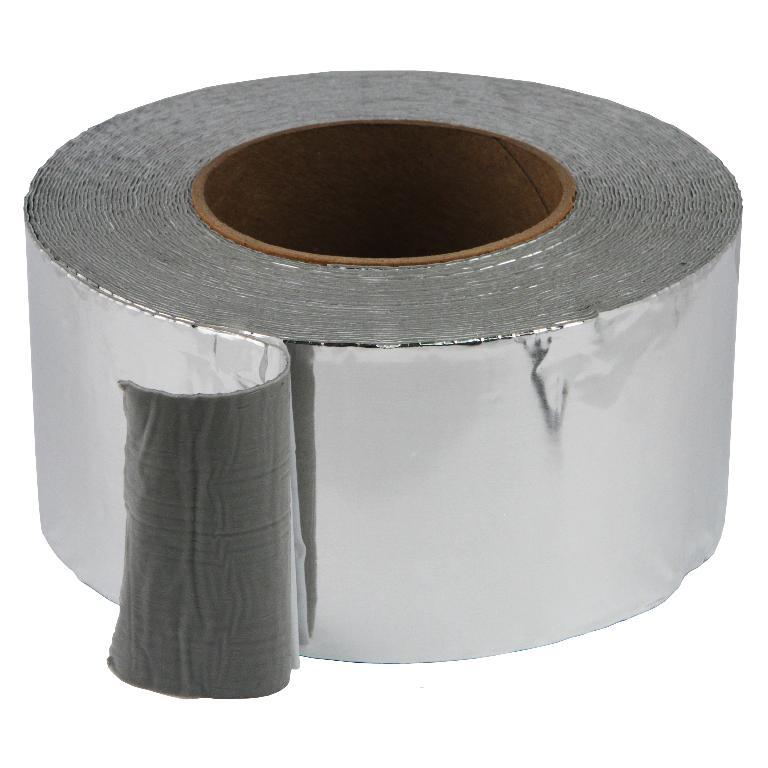What object can be seen in the image? There is a roll of tape in the image. What color is the background of the image? The background of the image is white. How many buns are present in the image? There are no buns present in the image; it only features a roll of tape against a white background. 